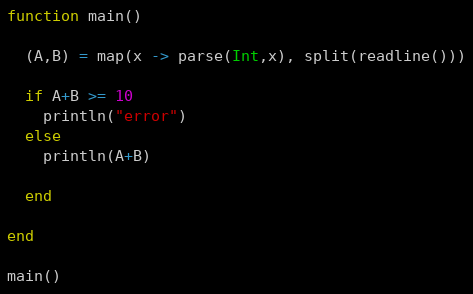<code> <loc_0><loc_0><loc_500><loc_500><_Julia_>function main()
  
  (A,B) = map(x -> parse(Int,x), split(readline()))
  
  if A+B >= 10
    println("error")
  else
    println(A+B)
    
  end
  
end

main()</code> 